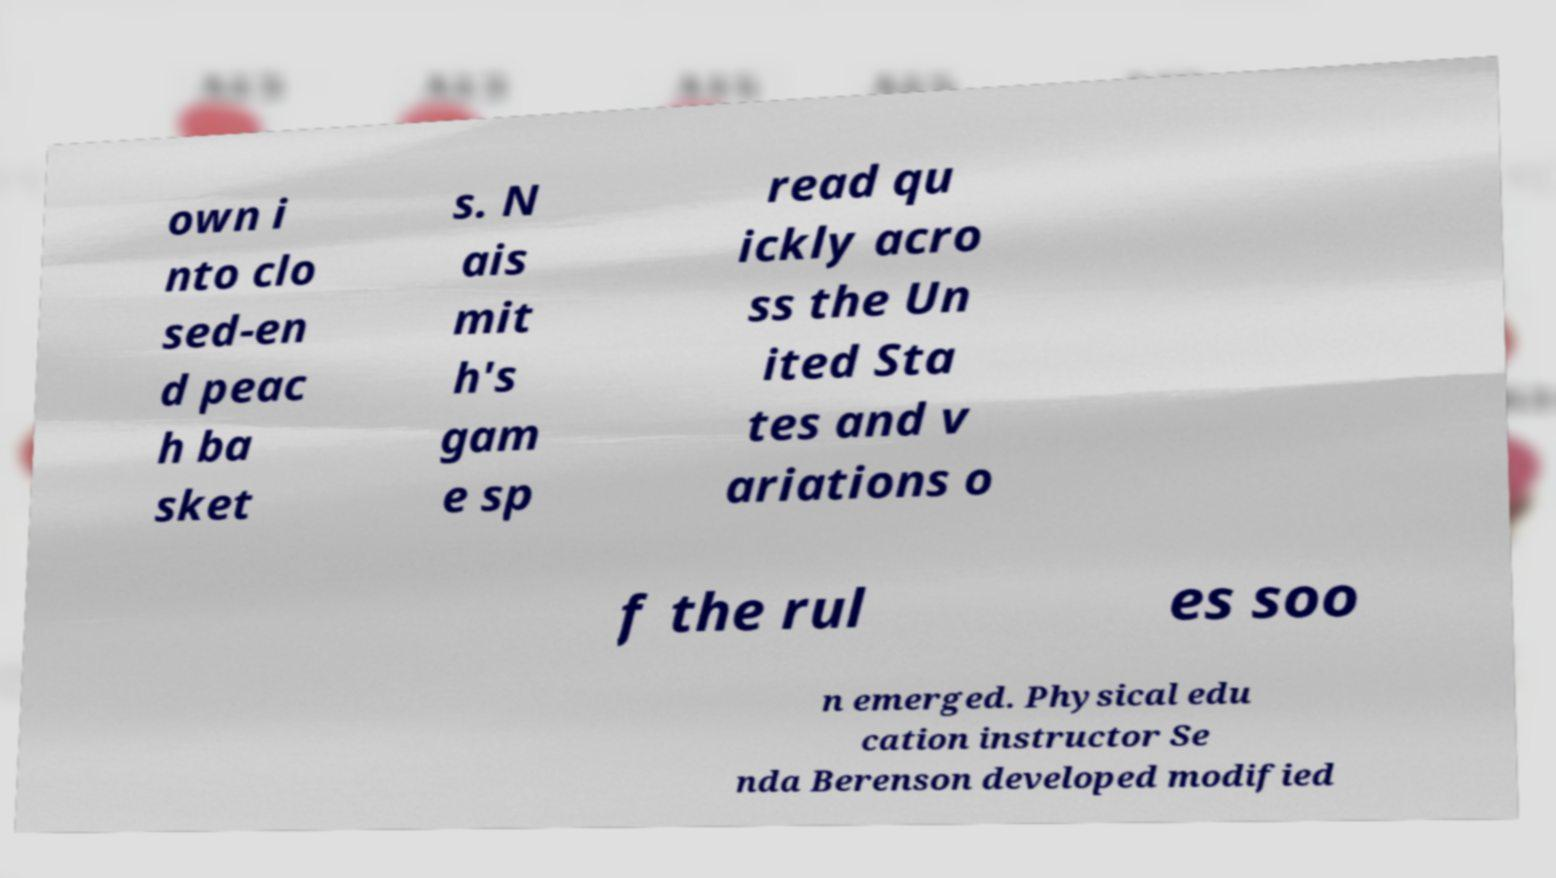Can you read and provide the text displayed in the image?This photo seems to have some interesting text. Can you extract and type it out for me? own i nto clo sed-en d peac h ba sket s. N ais mit h's gam e sp read qu ickly acro ss the Un ited Sta tes and v ariations o f the rul es soo n emerged. Physical edu cation instructor Se nda Berenson developed modified 